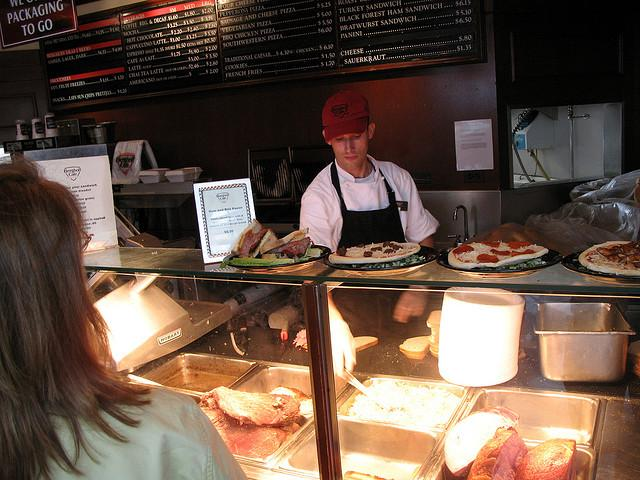What type of meat is most visible near the front of the glass? steak 